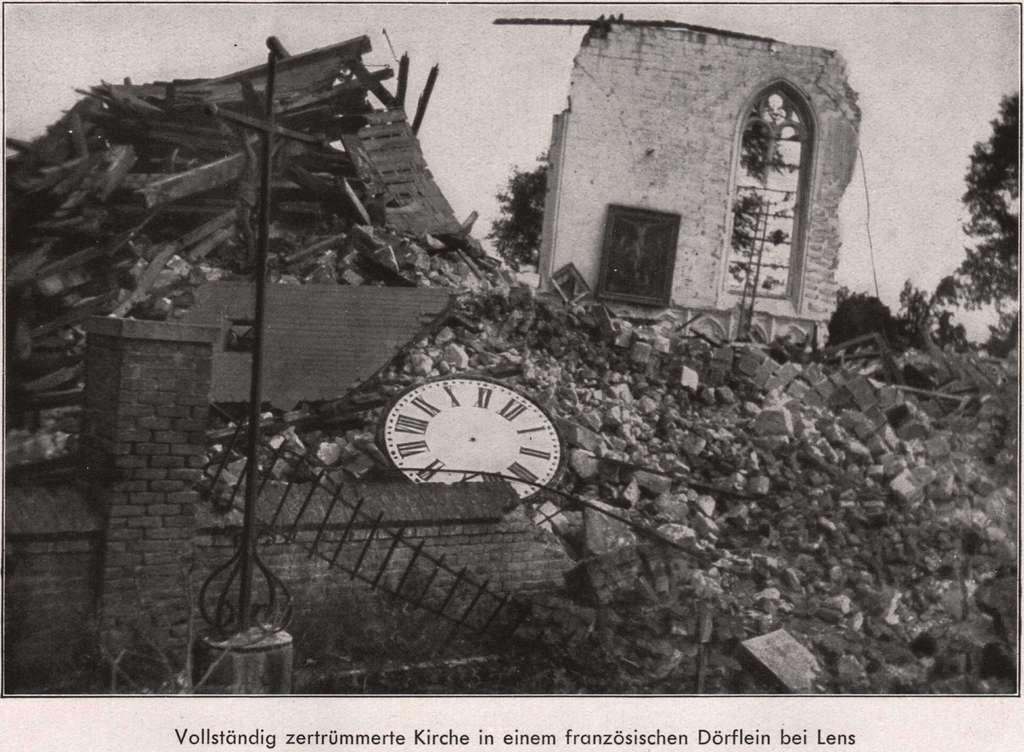<image>
Share a concise interpretation of the image provided. A picture of rubble with a German caption. 